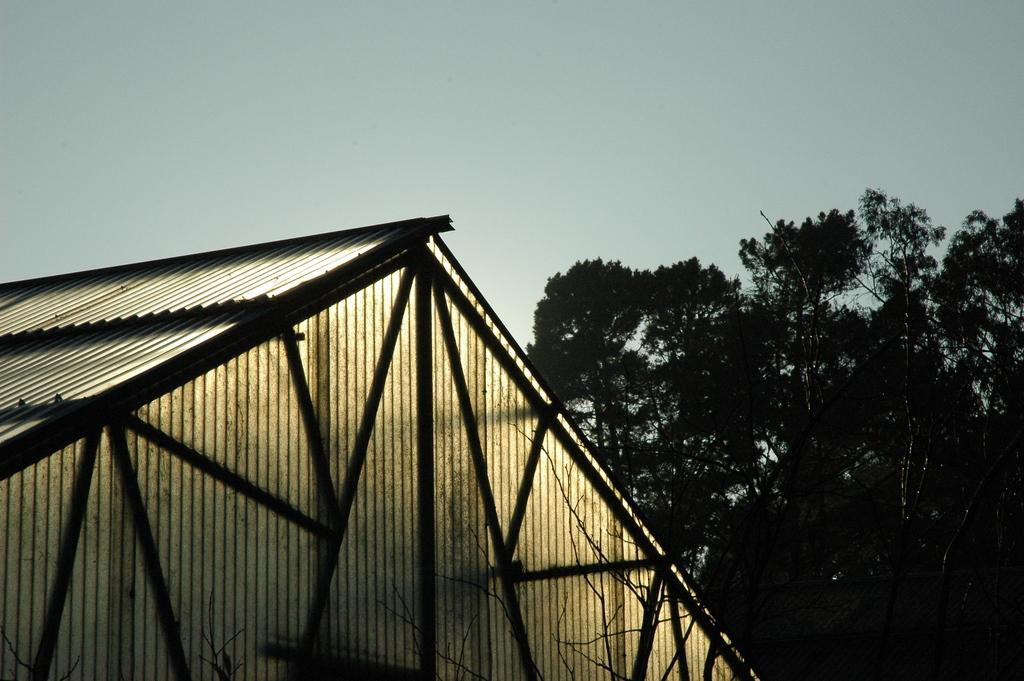What type of structure can be seen in the image? There is a shed in the image. What natural elements are present in the image? There are many trees in the image. What part of the environment is visible in the image? The sky is visible in the image. What theory is being tested in the image? There is no theory being tested in the image; it simply shows a shed, trees, and the sky. 